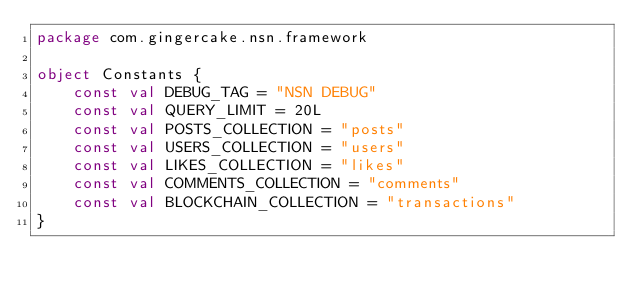<code> <loc_0><loc_0><loc_500><loc_500><_Kotlin_>package com.gingercake.nsn.framework

object Constants {
    const val DEBUG_TAG = "NSN DEBUG"
    const val QUERY_LIMIT = 20L
    const val POSTS_COLLECTION = "posts"
    const val USERS_COLLECTION = "users"
    const val LIKES_COLLECTION = "likes"
    const val COMMENTS_COLLECTION = "comments"
    const val BLOCKCHAIN_COLLECTION = "transactions"
}</code> 